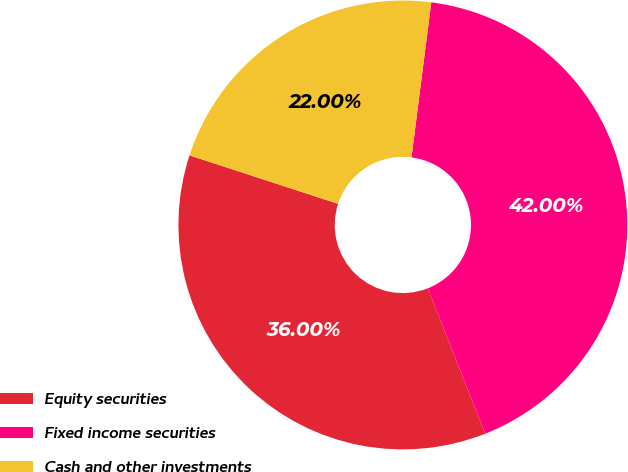Convert chart. <chart><loc_0><loc_0><loc_500><loc_500><pie_chart><fcel>Equity securities<fcel>Fixed income securities<fcel>Cash and other investments<nl><fcel>36.0%<fcel>42.0%<fcel>22.0%<nl></chart> 